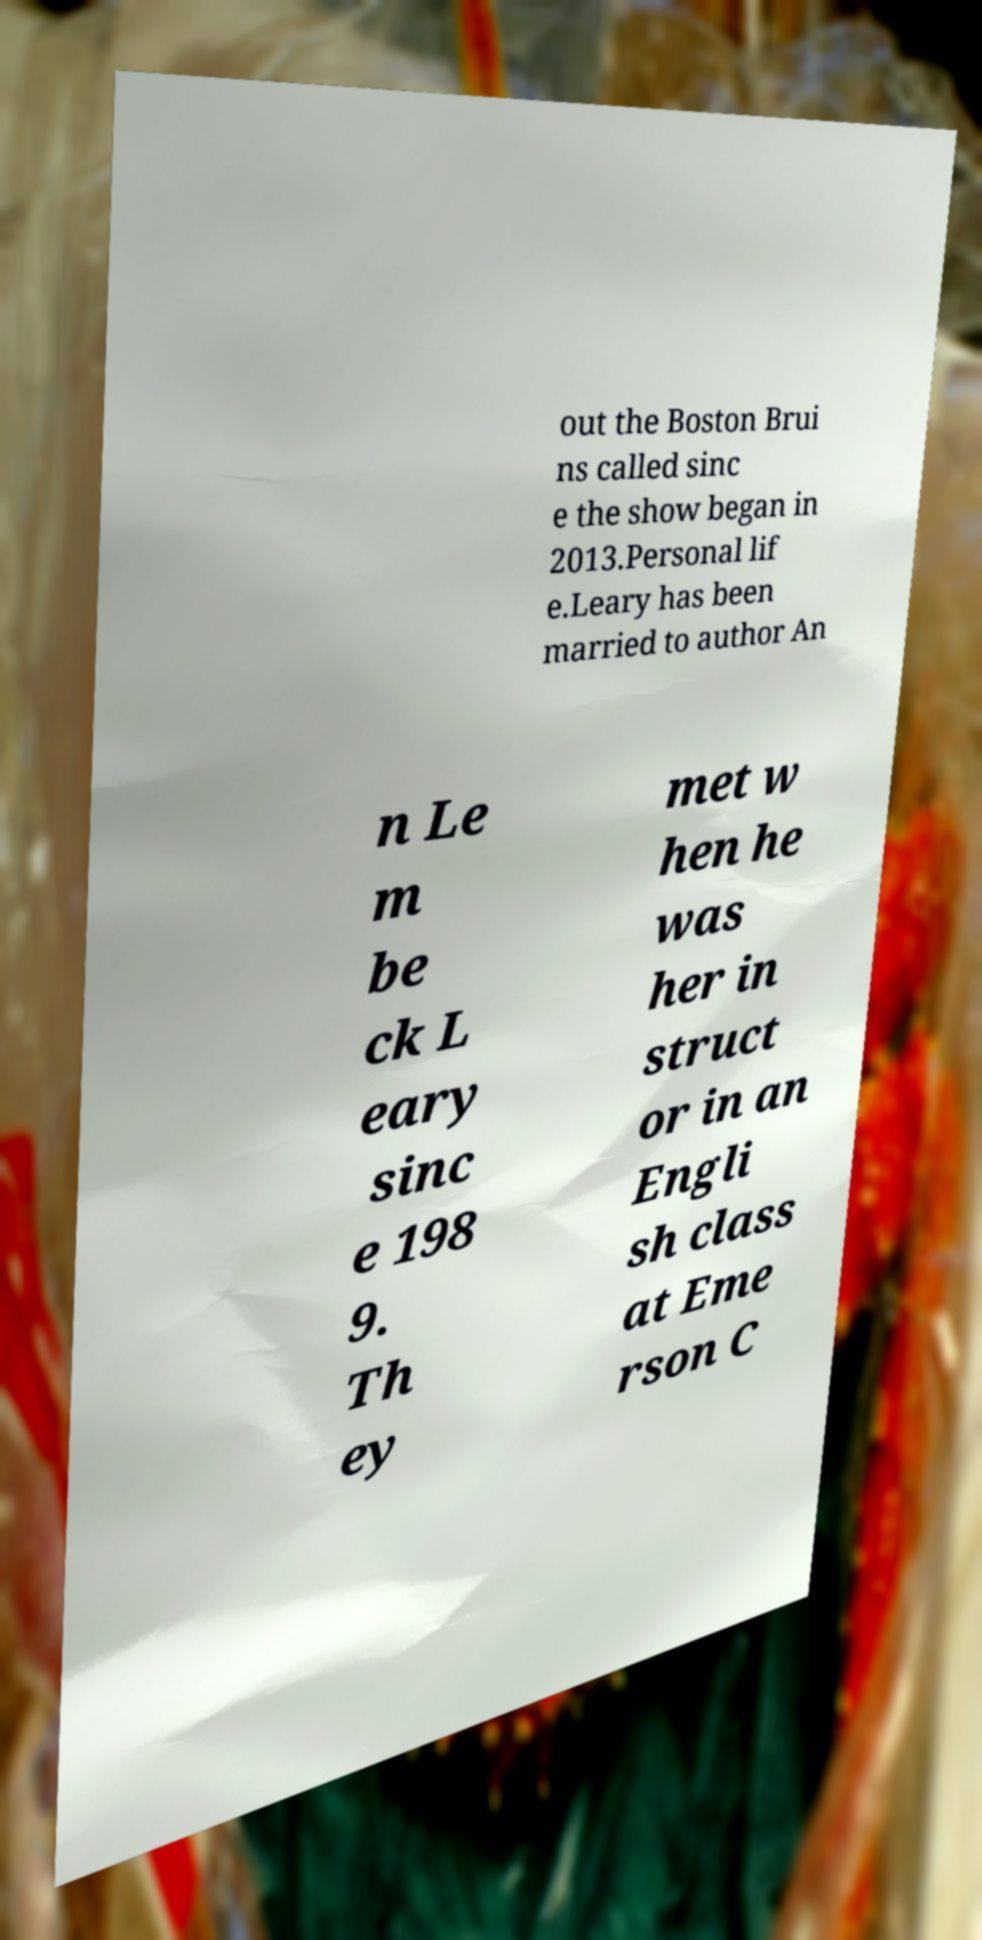There's text embedded in this image that I need extracted. Can you transcribe it verbatim? out the Boston Brui ns called sinc e the show began in 2013.Personal lif e.Leary has been married to author An n Le m be ck L eary sinc e 198 9. Th ey met w hen he was her in struct or in an Engli sh class at Eme rson C 